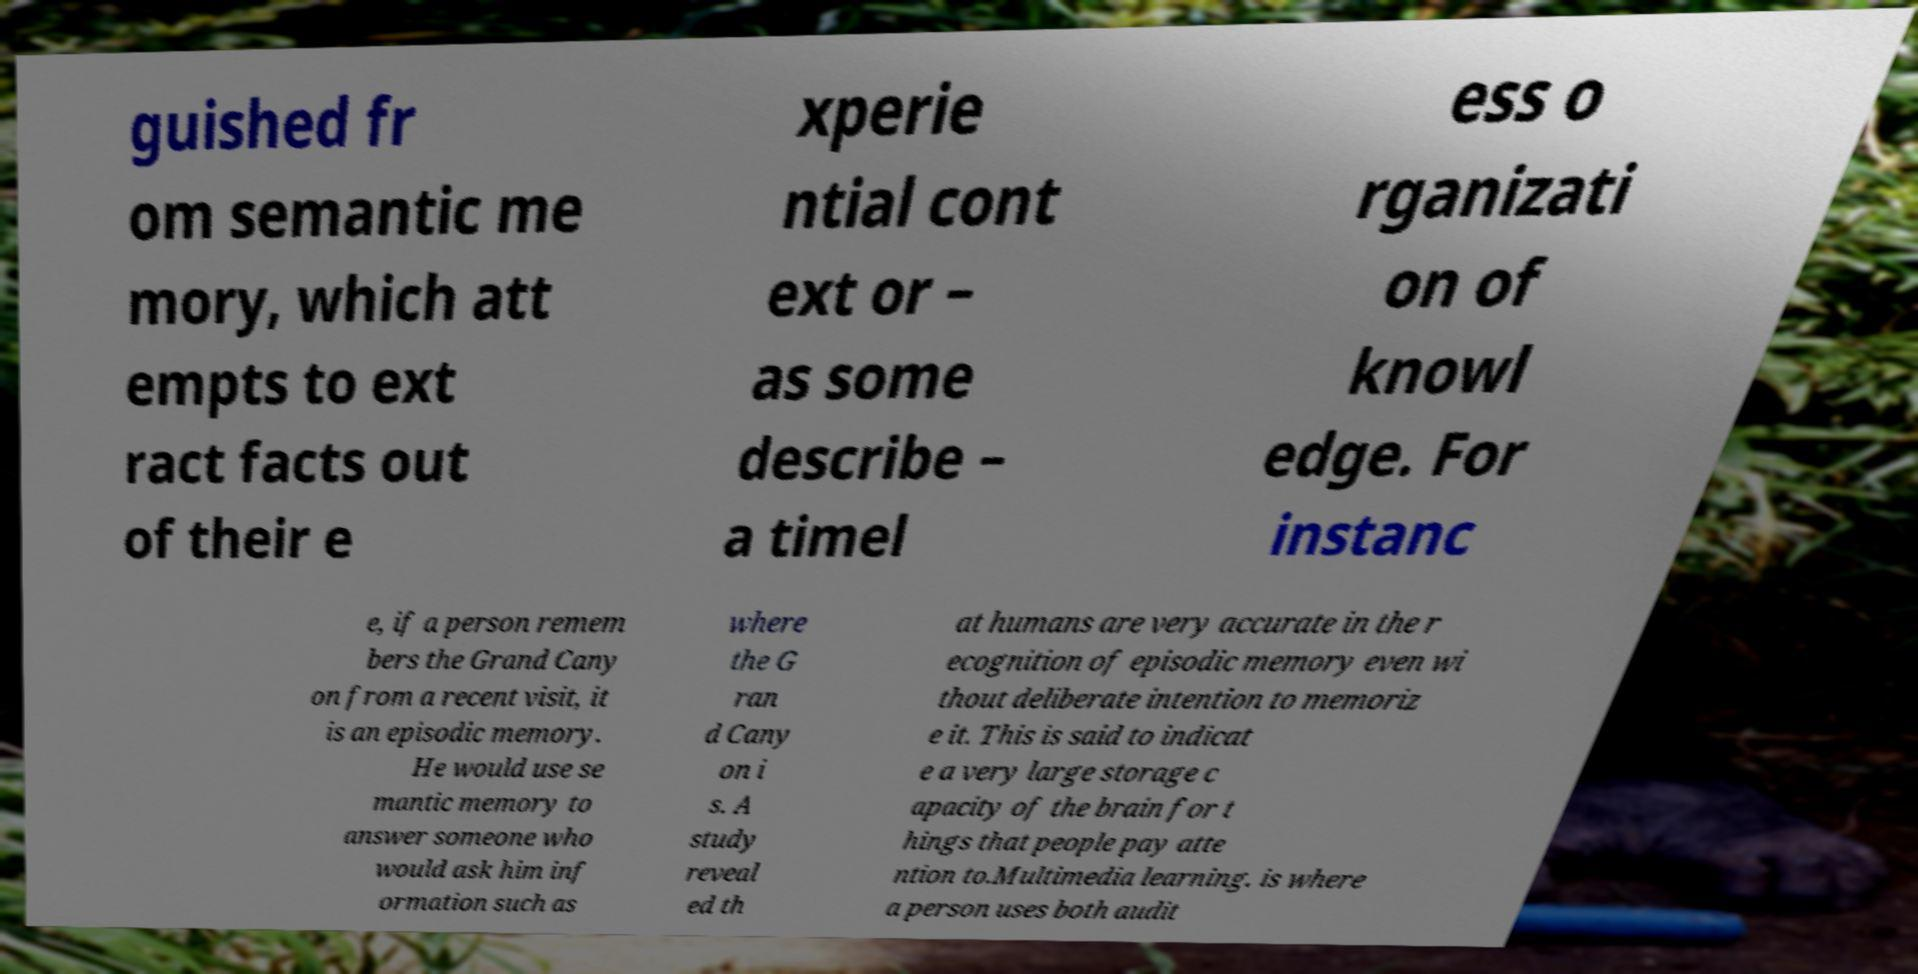Please read and relay the text visible in this image. What does it say? guished fr om semantic me mory, which att empts to ext ract facts out of their e xperie ntial cont ext or – as some describe – a timel ess o rganizati on of knowl edge. For instanc e, if a person remem bers the Grand Cany on from a recent visit, it is an episodic memory. He would use se mantic memory to answer someone who would ask him inf ormation such as where the G ran d Cany on i s. A study reveal ed th at humans are very accurate in the r ecognition of episodic memory even wi thout deliberate intention to memoriz e it. This is said to indicat e a very large storage c apacity of the brain for t hings that people pay atte ntion to.Multimedia learning. is where a person uses both audit 